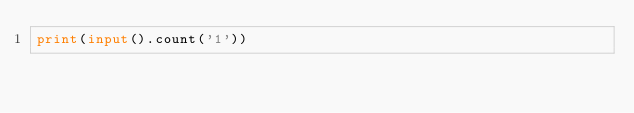Convert code to text. <code><loc_0><loc_0><loc_500><loc_500><_Python_>print(input().count('1'))</code> 